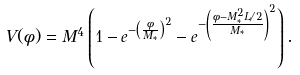<formula> <loc_0><loc_0><loc_500><loc_500>V ( \phi ) = M ^ { 4 } \left ( 1 - e ^ { - \left ( \frac { \phi } { M _ { * } } \right ) ^ { 2 } } - e ^ { - \left ( \frac { \phi - M _ { * } ^ { 2 } L / 2 } { M _ { * } } \right ) ^ { 2 } } \right ) .</formula> 